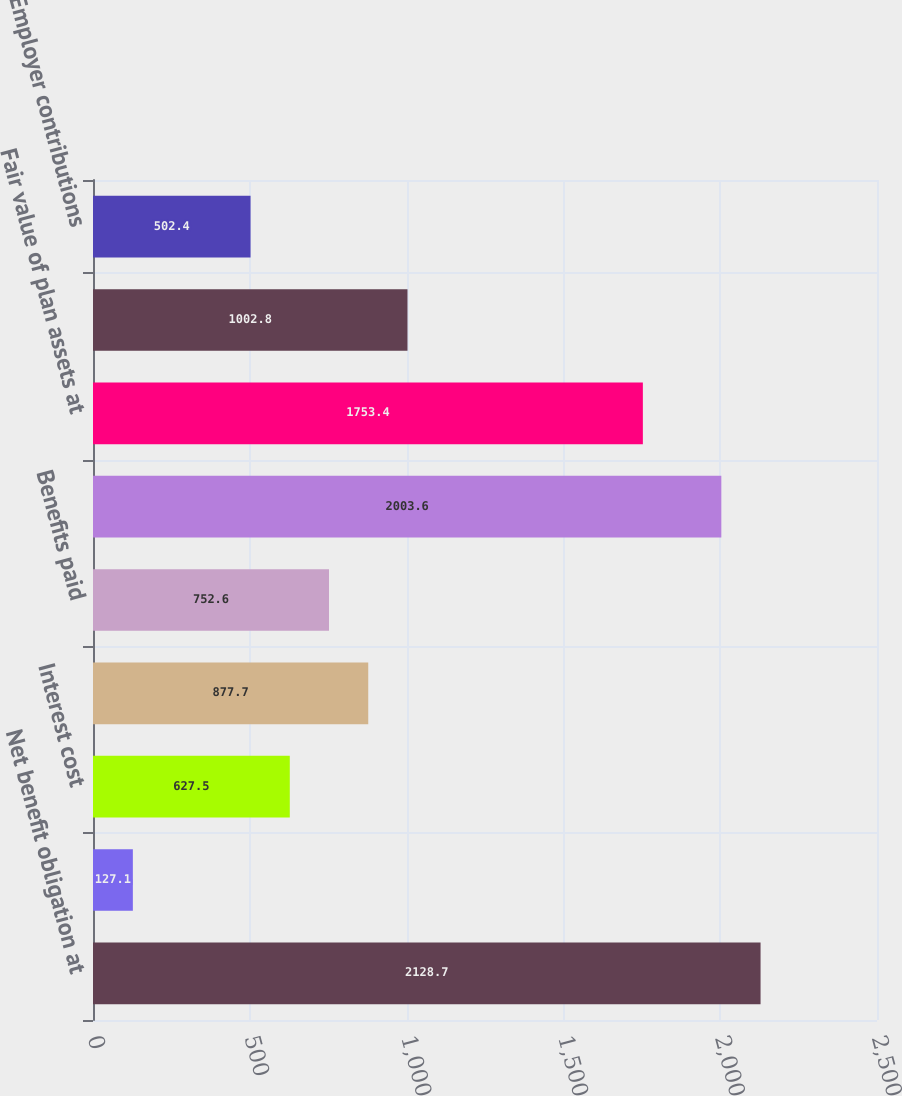Convert chart to OTSL. <chart><loc_0><loc_0><loc_500><loc_500><bar_chart><fcel>Net benefit obligation at<fcel>Service cost<fcel>Interest cost<fcel>Actuarial (gain) loss<fcel>Benefits paid<fcel>Net benefit obligation at end<fcel>Fair value of plan assets at<fcel>Actual return on plan assets<fcel>Employer contributions<nl><fcel>2128.7<fcel>127.1<fcel>627.5<fcel>877.7<fcel>752.6<fcel>2003.6<fcel>1753.4<fcel>1002.8<fcel>502.4<nl></chart> 